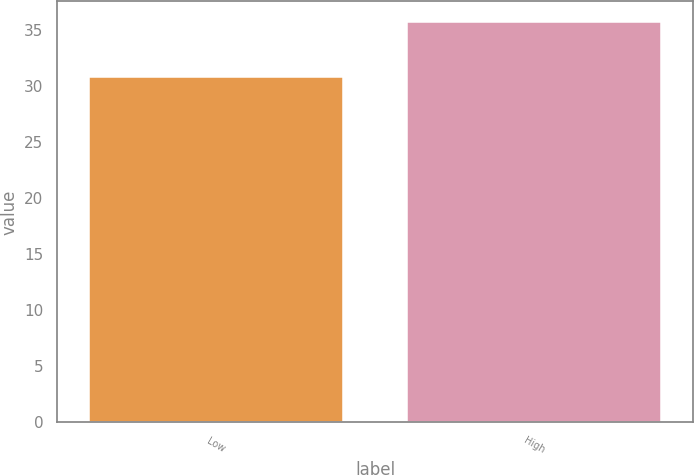Convert chart. <chart><loc_0><loc_0><loc_500><loc_500><bar_chart><fcel>Low<fcel>High<nl><fcel>30.84<fcel>35.78<nl></chart> 